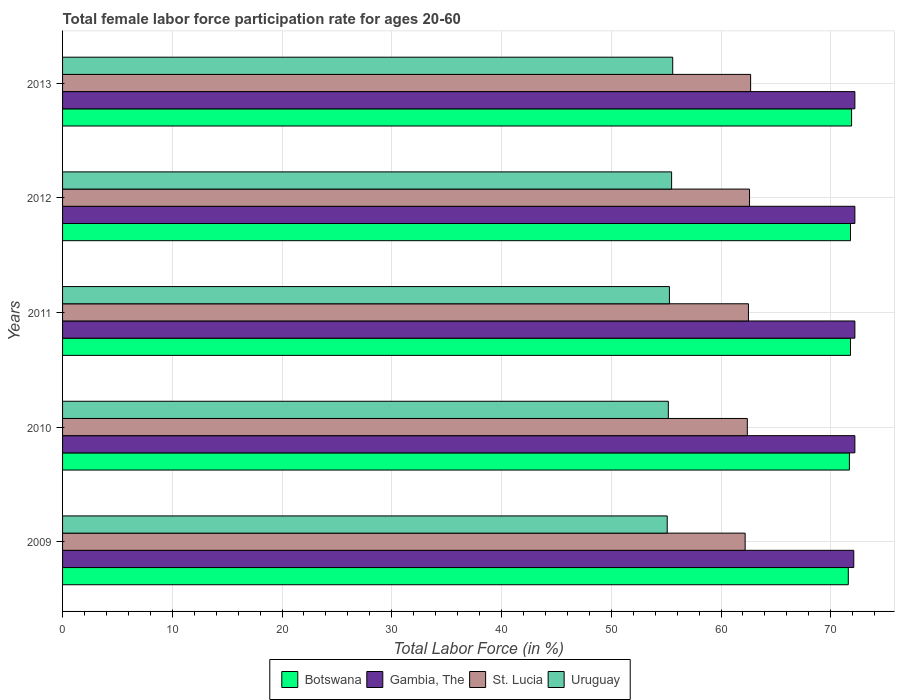How many different coloured bars are there?
Offer a very short reply. 4. How many groups of bars are there?
Keep it short and to the point. 5. How many bars are there on the 1st tick from the top?
Your answer should be compact. 4. In how many cases, is the number of bars for a given year not equal to the number of legend labels?
Offer a very short reply. 0. What is the female labor force participation rate in Uruguay in 2011?
Provide a succinct answer. 55.3. Across all years, what is the maximum female labor force participation rate in St. Lucia?
Give a very brief answer. 62.7. Across all years, what is the minimum female labor force participation rate in Botswana?
Keep it short and to the point. 71.6. What is the total female labor force participation rate in Uruguay in the graph?
Your response must be concise. 276.7. What is the difference between the female labor force participation rate in Botswana in 2010 and that in 2013?
Make the answer very short. -0.2. What is the average female labor force participation rate in Botswana per year?
Ensure brevity in your answer.  71.76. In the year 2013, what is the difference between the female labor force participation rate in Gambia, The and female labor force participation rate in Uruguay?
Your response must be concise. 16.6. In how many years, is the female labor force participation rate in Botswana greater than 4 %?
Ensure brevity in your answer.  5. What is the ratio of the female labor force participation rate in St. Lucia in 2010 to that in 2012?
Your response must be concise. 1. What is the difference between the highest and the lowest female labor force participation rate in Gambia, The?
Provide a succinct answer. 0.1. Is it the case that in every year, the sum of the female labor force participation rate in St. Lucia and female labor force participation rate in Uruguay is greater than the sum of female labor force participation rate in Botswana and female labor force participation rate in Gambia, The?
Your answer should be very brief. Yes. What does the 2nd bar from the top in 2011 represents?
Your answer should be compact. St. Lucia. What does the 2nd bar from the bottom in 2012 represents?
Offer a very short reply. Gambia, The. Is it the case that in every year, the sum of the female labor force participation rate in Gambia, The and female labor force participation rate in St. Lucia is greater than the female labor force participation rate in Uruguay?
Give a very brief answer. Yes. How many years are there in the graph?
Offer a terse response. 5. Does the graph contain grids?
Offer a terse response. Yes. What is the title of the graph?
Your response must be concise. Total female labor force participation rate for ages 20-60. Does "Myanmar" appear as one of the legend labels in the graph?
Your response must be concise. No. What is the Total Labor Force (in %) of Botswana in 2009?
Your response must be concise. 71.6. What is the Total Labor Force (in %) in Gambia, The in 2009?
Give a very brief answer. 72.1. What is the Total Labor Force (in %) in St. Lucia in 2009?
Offer a terse response. 62.2. What is the Total Labor Force (in %) in Uruguay in 2009?
Provide a succinct answer. 55.1. What is the Total Labor Force (in %) in Botswana in 2010?
Provide a succinct answer. 71.7. What is the Total Labor Force (in %) of Gambia, The in 2010?
Keep it short and to the point. 72.2. What is the Total Labor Force (in %) of St. Lucia in 2010?
Provide a short and direct response. 62.4. What is the Total Labor Force (in %) in Uruguay in 2010?
Offer a very short reply. 55.2. What is the Total Labor Force (in %) in Botswana in 2011?
Provide a short and direct response. 71.8. What is the Total Labor Force (in %) of Gambia, The in 2011?
Ensure brevity in your answer.  72.2. What is the Total Labor Force (in %) of St. Lucia in 2011?
Offer a very short reply. 62.5. What is the Total Labor Force (in %) in Uruguay in 2011?
Keep it short and to the point. 55.3. What is the Total Labor Force (in %) of Botswana in 2012?
Provide a succinct answer. 71.8. What is the Total Labor Force (in %) of Gambia, The in 2012?
Your response must be concise. 72.2. What is the Total Labor Force (in %) of St. Lucia in 2012?
Make the answer very short. 62.6. What is the Total Labor Force (in %) of Uruguay in 2012?
Keep it short and to the point. 55.5. What is the Total Labor Force (in %) in Botswana in 2013?
Provide a succinct answer. 71.9. What is the Total Labor Force (in %) in Gambia, The in 2013?
Ensure brevity in your answer.  72.2. What is the Total Labor Force (in %) in St. Lucia in 2013?
Your answer should be compact. 62.7. What is the Total Labor Force (in %) of Uruguay in 2013?
Your answer should be very brief. 55.6. Across all years, what is the maximum Total Labor Force (in %) of Botswana?
Your response must be concise. 71.9. Across all years, what is the maximum Total Labor Force (in %) in Gambia, The?
Your answer should be compact. 72.2. Across all years, what is the maximum Total Labor Force (in %) in St. Lucia?
Keep it short and to the point. 62.7. Across all years, what is the maximum Total Labor Force (in %) of Uruguay?
Offer a very short reply. 55.6. Across all years, what is the minimum Total Labor Force (in %) of Botswana?
Give a very brief answer. 71.6. Across all years, what is the minimum Total Labor Force (in %) in Gambia, The?
Give a very brief answer. 72.1. Across all years, what is the minimum Total Labor Force (in %) in St. Lucia?
Offer a very short reply. 62.2. Across all years, what is the minimum Total Labor Force (in %) of Uruguay?
Make the answer very short. 55.1. What is the total Total Labor Force (in %) of Botswana in the graph?
Your response must be concise. 358.8. What is the total Total Labor Force (in %) of Gambia, The in the graph?
Offer a very short reply. 360.9. What is the total Total Labor Force (in %) in St. Lucia in the graph?
Your answer should be compact. 312.4. What is the total Total Labor Force (in %) of Uruguay in the graph?
Provide a succinct answer. 276.7. What is the difference between the Total Labor Force (in %) in Gambia, The in 2009 and that in 2010?
Provide a succinct answer. -0.1. What is the difference between the Total Labor Force (in %) of St. Lucia in 2009 and that in 2010?
Your answer should be compact. -0.2. What is the difference between the Total Labor Force (in %) of Botswana in 2009 and that in 2011?
Your answer should be compact. -0.2. What is the difference between the Total Labor Force (in %) in Gambia, The in 2009 and that in 2011?
Provide a short and direct response. -0.1. What is the difference between the Total Labor Force (in %) in Uruguay in 2009 and that in 2011?
Your response must be concise. -0.2. What is the difference between the Total Labor Force (in %) in Gambia, The in 2009 and that in 2012?
Make the answer very short. -0.1. What is the difference between the Total Labor Force (in %) of Uruguay in 2009 and that in 2012?
Provide a short and direct response. -0.4. What is the difference between the Total Labor Force (in %) of Gambia, The in 2010 and that in 2011?
Give a very brief answer. 0. What is the difference between the Total Labor Force (in %) of St. Lucia in 2010 and that in 2011?
Your answer should be very brief. -0.1. What is the difference between the Total Labor Force (in %) in Uruguay in 2010 and that in 2011?
Make the answer very short. -0.1. What is the difference between the Total Labor Force (in %) of Botswana in 2010 and that in 2012?
Offer a terse response. -0.1. What is the difference between the Total Labor Force (in %) of Gambia, The in 2010 and that in 2012?
Ensure brevity in your answer.  0. What is the difference between the Total Labor Force (in %) of St. Lucia in 2010 and that in 2012?
Ensure brevity in your answer.  -0.2. What is the difference between the Total Labor Force (in %) in Uruguay in 2010 and that in 2012?
Offer a very short reply. -0.3. What is the difference between the Total Labor Force (in %) in Botswana in 2010 and that in 2013?
Your response must be concise. -0.2. What is the difference between the Total Labor Force (in %) of Uruguay in 2010 and that in 2013?
Make the answer very short. -0.4. What is the difference between the Total Labor Force (in %) in Uruguay in 2011 and that in 2012?
Keep it short and to the point. -0.2. What is the difference between the Total Labor Force (in %) in Botswana in 2011 and that in 2013?
Your answer should be compact. -0.1. What is the difference between the Total Labor Force (in %) of Gambia, The in 2011 and that in 2013?
Ensure brevity in your answer.  0. What is the difference between the Total Labor Force (in %) in St. Lucia in 2011 and that in 2013?
Your response must be concise. -0.2. What is the difference between the Total Labor Force (in %) in Uruguay in 2011 and that in 2013?
Offer a terse response. -0.3. What is the difference between the Total Labor Force (in %) of Gambia, The in 2012 and that in 2013?
Your answer should be very brief. 0. What is the difference between the Total Labor Force (in %) of St. Lucia in 2012 and that in 2013?
Make the answer very short. -0.1. What is the difference between the Total Labor Force (in %) in Botswana in 2009 and the Total Labor Force (in %) in St. Lucia in 2010?
Your response must be concise. 9.2. What is the difference between the Total Labor Force (in %) of Gambia, The in 2009 and the Total Labor Force (in %) of St. Lucia in 2010?
Your answer should be very brief. 9.7. What is the difference between the Total Labor Force (in %) in Botswana in 2009 and the Total Labor Force (in %) in Gambia, The in 2011?
Your answer should be compact. -0.6. What is the difference between the Total Labor Force (in %) of Botswana in 2009 and the Total Labor Force (in %) of Uruguay in 2011?
Provide a short and direct response. 16.3. What is the difference between the Total Labor Force (in %) of Gambia, The in 2009 and the Total Labor Force (in %) of Uruguay in 2011?
Ensure brevity in your answer.  16.8. What is the difference between the Total Labor Force (in %) of St. Lucia in 2009 and the Total Labor Force (in %) of Uruguay in 2011?
Ensure brevity in your answer.  6.9. What is the difference between the Total Labor Force (in %) in Botswana in 2009 and the Total Labor Force (in %) in St. Lucia in 2012?
Offer a very short reply. 9. What is the difference between the Total Labor Force (in %) in Gambia, The in 2009 and the Total Labor Force (in %) in St. Lucia in 2012?
Offer a terse response. 9.5. What is the difference between the Total Labor Force (in %) of St. Lucia in 2009 and the Total Labor Force (in %) of Uruguay in 2012?
Your answer should be compact. 6.7. What is the difference between the Total Labor Force (in %) in Botswana in 2009 and the Total Labor Force (in %) in St. Lucia in 2013?
Offer a very short reply. 8.9. What is the difference between the Total Labor Force (in %) in Gambia, The in 2009 and the Total Labor Force (in %) in St. Lucia in 2013?
Ensure brevity in your answer.  9.4. What is the difference between the Total Labor Force (in %) of St. Lucia in 2009 and the Total Labor Force (in %) of Uruguay in 2013?
Ensure brevity in your answer.  6.6. What is the difference between the Total Labor Force (in %) in Botswana in 2010 and the Total Labor Force (in %) in St. Lucia in 2011?
Your answer should be compact. 9.2. What is the difference between the Total Labor Force (in %) of Botswana in 2010 and the Total Labor Force (in %) of Uruguay in 2011?
Give a very brief answer. 16.4. What is the difference between the Total Labor Force (in %) in Gambia, The in 2010 and the Total Labor Force (in %) in St. Lucia in 2011?
Provide a succinct answer. 9.7. What is the difference between the Total Labor Force (in %) in Gambia, The in 2010 and the Total Labor Force (in %) in Uruguay in 2011?
Your answer should be very brief. 16.9. What is the difference between the Total Labor Force (in %) of St. Lucia in 2010 and the Total Labor Force (in %) of Uruguay in 2011?
Provide a short and direct response. 7.1. What is the difference between the Total Labor Force (in %) in Botswana in 2010 and the Total Labor Force (in %) in St. Lucia in 2012?
Your answer should be very brief. 9.1. What is the difference between the Total Labor Force (in %) of Gambia, The in 2010 and the Total Labor Force (in %) of St. Lucia in 2012?
Offer a terse response. 9.6. What is the difference between the Total Labor Force (in %) of St. Lucia in 2010 and the Total Labor Force (in %) of Uruguay in 2012?
Your answer should be very brief. 6.9. What is the difference between the Total Labor Force (in %) of Botswana in 2010 and the Total Labor Force (in %) of Gambia, The in 2013?
Provide a short and direct response. -0.5. What is the difference between the Total Labor Force (in %) of Botswana in 2010 and the Total Labor Force (in %) of Uruguay in 2013?
Make the answer very short. 16.1. What is the difference between the Total Labor Force (in %) in Gambia, The in 2010 and the Total Labor Force (in %) in St. Lucia in 2013?
Ensure brevity in your answer.  9.5. What is the difference between the Total Labor Force (in %) in Gambia, The in 2010 and the Total Labor Force (in %) in Uruguay in 2013?
Your answer should be very brief. 16.6. What is the difference between the Total Labor Force (in %) in Botswana in 2011 and the Total Labor Force (in %) in Gambia, The in 2012?
Your answer should be compact. -0.4. What is the difference between the Total Labor Force (in %) of Gambia, The in 2011 and the Total Labor Force (in %) of St. Lucia in 2012?
Make the answer very short. 9.6. What is the difference between the Total Labor Force (in %) in St. Lucia in 2011 and the Total Labor Force (in %) in Uruguay in 2012?
Offer a very short reply. 7. What is the difference between the Total Labor Force (in %) of Botswana in 2011 and the Total Labor Force (in %) of Gambia, The in 2013?
Offer a very short reply. -0.4. What is the difference between the Total Labor Force (in %) in Gambia, The in 2011 and the Total Labor Force (in %) in Uruguay in 2013?
Your answer should be compact. 16.6. What is the difference between the Total Labor Force (in %) in Botswana in 2012 and the Total Labor Force (in %) in Gambia, The in 2013?
Offer a very short reply. -0.4. What is the difference between the Total Labor Force (in %) in Botswana in 2012 and the Total Labor Force (in %) in Uruguay in 2013?
Your response must be concise. 16.2. What is the difference between the Total Labor Force (in %) in Gambia, The in 2012 and the Total Labor Force (in %) in St. Lucia in 2013?
Offer a very short reply. 9.5. What is the difference between the Total Labor Force (in %) of Gambia, The in 2012 and the Total Labor Force (in %) of Uruguay in 2013?
Give a very brief answer. 16.6. What is the average Total Labor Force (in %) of Botswana per year?
Your answer should be very brief. 71.76. What is the average Total Labor Force (in %) in Gambia, The per year?
Offer a very short reply. 72.18. What is the average Total Labor Force (in %) of St. Lucia per year?
Offer a terse response. 62.48. What is the average Total Labor Force (in %) in Uruguay per year?
Offer a very short reply. 55.34. In the year 2009, what is the difference between the Total Labor Force (in %) of Botswana and Total Labor Force (in %) of Gambia, The?
Offer a very short reply. -0.5. In the year 2009, what is the difference between the Total Labor Force (in %) in Botswana and Total Labor Force (in %) in St. Lucia?
Offer a very short reply. 9.4. In the year 2009, what is the difference between the Total Labor Force (in %) in Botswana and Total Labor Force (in %) in Uruguay?
Your answer should be compact. 16.5. In the year 2009, what is the difference between the Total Labor Force (in %) of Gambia, The and Total Labor Force (in %) of Uruguay?
Your response must be concise. 17. In the year 2009, what is the difference between the Total Labor Force (in %) in St. Lucia and Total Labor Force (in %) in Uruguay?
Give a very brief answer. 7.1. In the year 2010, what is the difference between the Total Labor Force (in %) of Botswana and Total Labor Force (in %) of Gambia, The?
Your answer should be compact. -0.5. In the year 2010, what is the difference between the Total Labor Force (in %) in Botswana and Total Labor Force (in %) in St. Lucia?
Keep it short and to the point. 9.3. In the year 2010, what is the difference between the Total Labor Force (in %) in Botswana and Total Labor Force (in %) in Uruguay?
Your response must be concise. 16.5. In the year 2010, what is the difference between the Total Labor Force (in %) in Gambia, The and Total Labor Force (in %) in St. Lucia?
Give a very brief answer. 9.8. In the year 2010, what is the difference between the Total Labor Force (in %) in St. Lucia and Total Labor Force (in %) in Uruguay?
Ensure brevity in your answer.  7.2. In the year 2011, what is the difference between the Total Labor Force (in %) in Botswana and Total Labor Force (in %) in St. Lucia?
Keep it short and to the point. 9.3. In the year 2011, what is the difference between the Total Labor Force (in %) of Botswana and Total Labor Force (in %) of Uruguay?
Give a very brief answer. 16.5. In the year 2011, what is the difference between the Total Labor Force (in %) of Gambia, The and Total Labor Force (in %) of St. Lucia?
Provide a short and direct response. 9.7. In the year 2011, what is the difference between the Total Labor Force (in %) of Gambia, The and Total Labor Force (in %) of Uruguay?
Your answer should be compact. 16.9. In the year 2012, what is the difference between the Total Labor Force (in %) in Botswana and Total Labor Force (in %) in Gambia, The?
Your answer should be compact. -0.4. In the year 2012, what is the difference between the Total Labor Force (in %) in Gambia, The and Total Labor Force (in %) in St. Lucia?
Provide a succinct answer. 9.6. In the year 2012, what is the difference between the Total Labor Force (in %) of Gambia, The and Total Labor Force (in %) of Uruguay?
Offer a terse response. 16.7. In the year 2013, what is the difference between the Total Labor Force (in %) of Botswana and Total Labor Force (in %) of Uruguay?
Keep it short and to the point. 16.3. In the year 2013, what is the difference between the Total Labor Force (in %) of Gambia, The and Total Labor Force (in %) of Uruguay?
Provide a short and direct response. 16.6. What is the ratio of the Total Labor Force (in %) in St. Lucia in 2009 to that in 2010?
Offer a very short reply. 1. What is the ratio of the Total Labor Force (in %) in Uruguay in 2009 to that in 2010?
Give a very brief answer. 1. What is the ratio of the Total Labor Force (in %) in Gambia, The in 2009 to that in 2011?
Offer a very short reply. 1. What is the ratio of the Total Labor Force (in %) in St. Lucia in 2009 to that in 2012?
Your answer should be very brief. 0.99. What is the ratio of the Total Labor Force (in %) in Uruguay in 2009 to that in 2012?
Provide a short and direct response. 0.99. What is the ratio of the Total Labor Force (in %) in Gambia, The in 2009 to that in 2013?
Your answer should be compact. 1. What is the ratio of the Total Labor Force (in %) in St. Lucia in 2009 to that in 2013?
Your answer should be compact. 0.99. What is the ratio of the Total Labor Force (in %) in Uruguay in 2009 to that in 2013?
Your response must be concise. 0.99. What is the ratio of the Total Labor Force (in %) in Uruguay in 2010 to that in 2011?
Your response must be concise. 1. What is the ratio of the Total Labor Force (in %) of Botswana in 2010 to that in 2012?
Your response must be concise. 1. What is the ratio of the Total Labor Force (in %) of Botswana in 2010 to that in 2013?
Offer a very short reply. 1. What is the ratio of the Total Labor Force (in %) of Uruguay in 2010 to that in 2013?
Offer a very short reply. 0.99. What is the ratio of the Total Labor Force (in %) of St. Lucia in 2011 to that in 2012?
Keep it short and to the point. 1. What is the ratio of the Total Labor Force (in %) in Uruguay in 2011 to that in 2012?
Offer a terse response. 1. What is the ratio of the Total Labor Force (in %) of Gambia, The in 2011 to that in 2013?
Keep it short and to the point. 1. What is the ratio of the Total Labor Force (in %) of St. Lucia in 2011 to that in 2013?
Offer a terse response. 1. What is the ratio of the Total Labor Force (in %) in Uruguay in 2011 to that in 2013?
Ensure brevity in your answer.  0.99. What is the ratio of the Total Labor Force (in %) in Botswana in 2012 to that in 2013?
Your answer should be very brief. 1. What is the ratio of the Total Labor Force (in %) of Gambia, The in 2012 to that in 2013?
Ensure brevity in your answer.  1. What is the difference between the highest and the second highest Total Labor Force (in %) of Botswana?
Offer a very short reply. 0.1. What is the difference between the highest and the second highest Total Labor Force (in %) in St. Lucia?
Provide a short and direct response. 0.1. What is the difference between the highest and the lowest Total Labor Force (in %) in Botswana?
Give a very brief answer. 0.3. What is the difference between the highest and the lowest Total Labor Force (in %) of Gambia, The?
Provide a succinct answer. 0.1. 